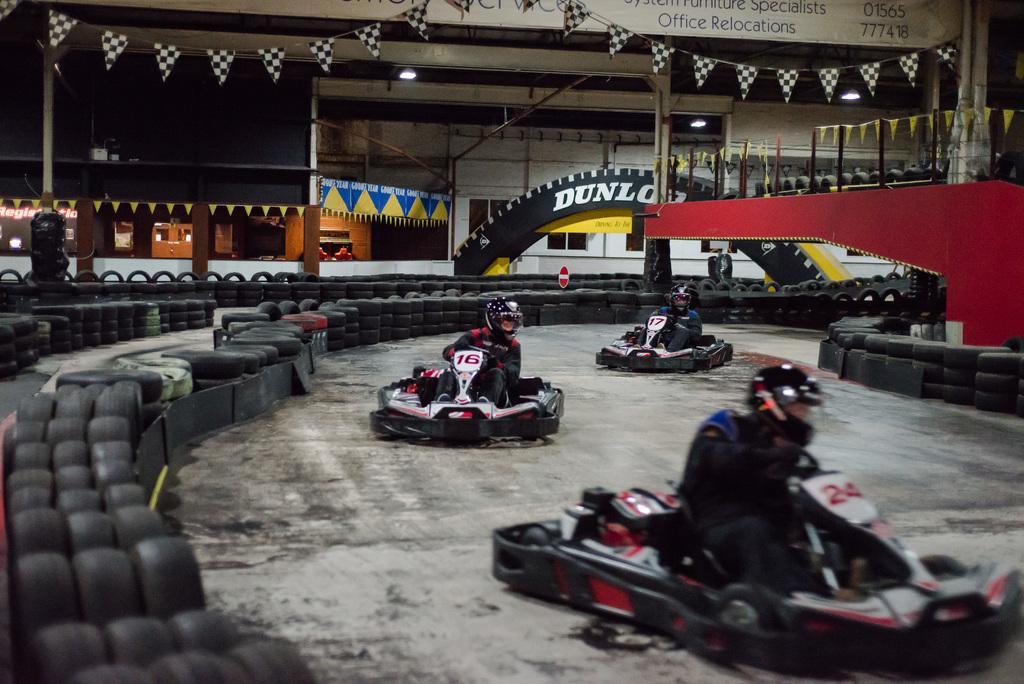Can you describe this image briefly? In this image there is go karting area in that there are three persons riding cars, in the background there are flags and tires. 